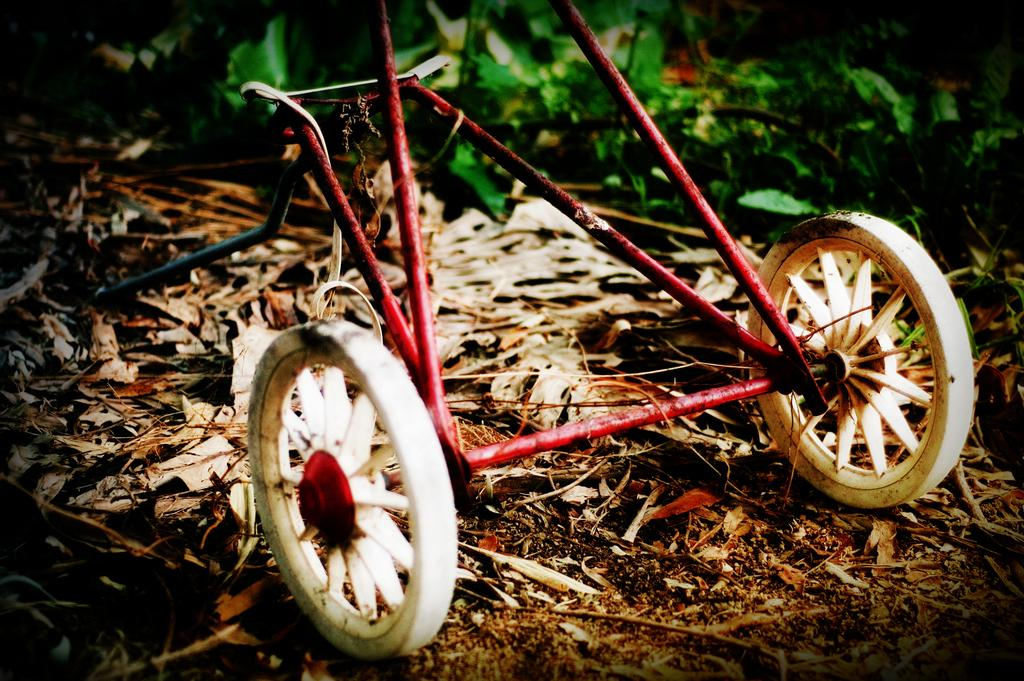What type of object with wheels can be seen in the image? There is a metallic object with wheels in the image. What is the condition of the ground in the image? The ground is visible with dry leaves. What can be seen in the background of the image? There are plants in the background of the image. What is the education level of the rock in the image? There is no rock present in the image, so it is not possible to determine its education level. 